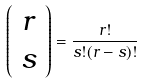<formula> <loc_0><loc_0><loc_500><loc_500>\left ( \begin{array} { c } r \\ s \end{array} \right ) = \frac { r ! } { s ! ( r - s ) ! }</formula> 